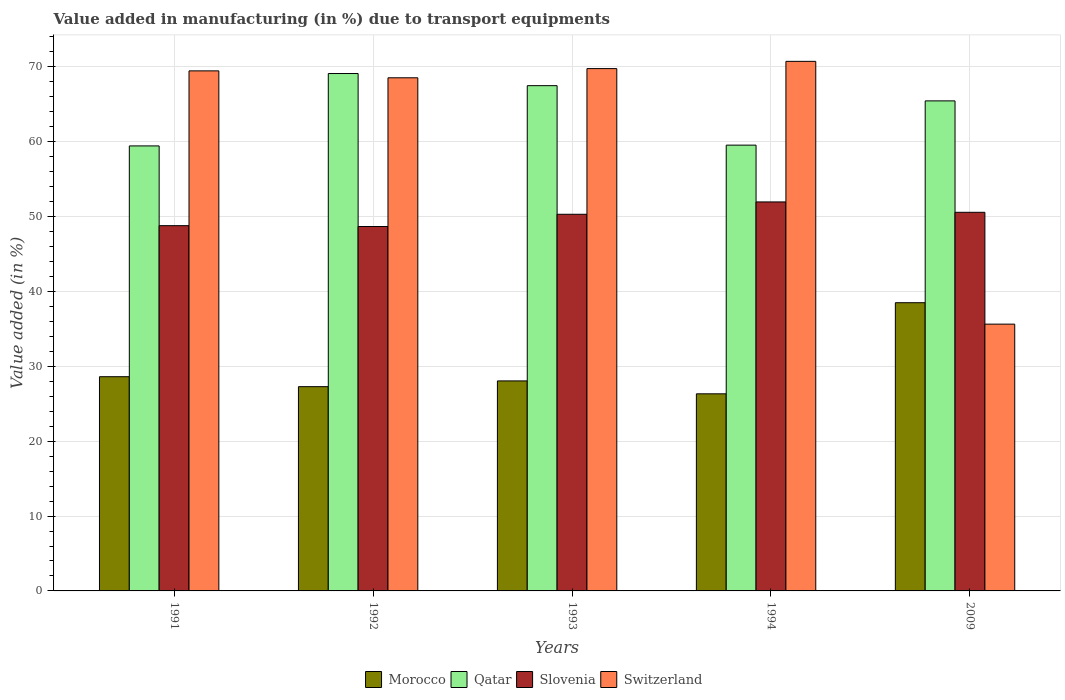How many different coloured bars are there?
Keep it short and to the point. 4. How many groups of bars are there?
Offer a very short reply. 5. Are the number of bars on each tick of the X-axis equal?
Make the answer very short. Yes. How many bars are there on the 4th tick from the left?
Make the answer very short. 4. How many bars are there on the 5th tick from the right?
Offer a very short reply. 4. In how many cases, is the number of bars for a given year not equal to the number of legend labels?
Give a very brief answer. 0. What is the percentage of value added in manufacturing due to transport equipments in Qatar in 1994?
Your response must be concise. 59.55. Across all years, what is the maximum percentage of value added in manufacturing due to transport equipments in Slovenia?
Your answer should be compact. 51.96. Across all years, what is the minimum percentage of value added in manufacturing due to transport equipments in Qatar?
Keep it short and to the point. 59.44. In which year was the percentage of value added in manufacturing due to transport equipments in Qatar maximum?
Make the answer very short. 1992. In which year was the percentage of value added in manufacturing due to transport equipments in Qatar minimum?
Offer a very short reply. 1991. What is the total percentage of value added in manufacturing due to transport equipments in Qatar in the graph?
Your response must be concise. 321.04. What is the difference between the percentage of value added in manufacturing due to transport equipments in Morocco in 1993 and that in 1994?
Provide a short and direct response. 1.72. What is the difference between the percentage of value added in manufacturing due to transport equipments in Qatar in 1993 and the percentage of value added in manufacturing due to transport equipments in Switzerland in 1994?
Provide a short and direct response. -3.25. What is the average percentage of value added in manufacturing due to transport equipments in Morocco per year?
Offer a very short reply. 29.75. In the year 1992, what is the difference between the percentage of value added in manufacturing due to transport equipments in Qatar and percentage of value added in manufacturing due to transport equipments in Switzerland?
Your answer should be compact. 0.57. In how many years, is the percentage of value added in manufacturing due to transport equipments in Morocco greater than 26 %?
Your answer should be very brief. 5. What is the ratio of the percentage of value added in manufacturing due to transport equipments in Qatar in 1993 to that in 2009?
Your answer should be very brief. 1.03. What is the difference between the highest and the second highest percentage of value added in manufacturing due to transport equipments in Qatar?
Offer a terse response. 1.62. What is the difference between the highest and the lowest percentage of value added in manufacturing due to transport equipments in Qatar?
Keep it short and to the point. 9.67. Is the sum of the percentage of value added in manufacturing due to transport equipments in Qatar in 1991 and 2009 greater than the maximum percentage of value added in manufacturing due to transport equipments in Morocco across all years?
Your answer should be very brief. Yes. What does the 4th bar from the left in 1993 represents?
Offer a very short reply. Switzerland. What does the 4th bar from the right in 1993 represents?
Provide a succinct answer. Morocco. Is it the case that in every year, the sum of the percentage of value added in manufacturing due to transport equipments in Morocco and percentage of value added in manufacturing due to transport equipments in Slovenia is greater than the percentage of value added in manufacturing due to transport equipments in Qatar?
Offer a terse response. Yes. Are all the bars in the graph horizontal?
Your answer should be very brief. No. How many years are there in the graph?
Give a very brief answer. 5. Are the values on the major ticks of Y-axis written in scientific E-notation?
Offer a terse response. No. Does the graph contain any zero values?
Your answer should be very brief. No. How many legend labels are there?
Make the answer very short. 4. How are the legend labels stacked?
Provide a succinct answer. Horizontal. What is the title of the graph?
Keep it short and to the point. Value added in manufacturing (in %) due to transport equipments. Does "Congo (Republic)" appear as one of the legend labels in the graph?
Offer a very short reply. No. What is the label or title of the X-axis?
Provide a succinct answer. Years. What is the label or title of the Y-axis?
Ensure brevity in your answer.  Value added (in %). What is the Value added (in %) in Morocco in 1991?
Give a very brief answer. 28.61. What is the Value added (in %) in Qatar in 1991?
Your response must be concise. 59.44. What is the Value added (in %) of Slovenia in 1991?
Provide a succinct answer. 48.79. What is the Value added (in %) of Switzerland in 1991?
Offer a terse response. 69.46. What is the Value added (in %) of Morocco in 1992?
Keep it short and to the point. 27.28. What is the Value added (in %) in Qatar in 1992?
Provide a short and direct response. 69.11. What is the Value added (in %) of Slovenia in 1992?
Offer a terse response. 48.68. What is the Value added (in %) in Switzerland in 1992?
Offer a very short reply. 68.54. What is the Value added (in %) in Morocco in 1993?
Ensure brevity in your answer.  28.05. What is the Value added (in %) in Qatar in 1993?
Make the answer very short. 67.49. What is the Value added (in %) of Slovenia in 1993?
Offer a very short reply. 50.31. What is the Value added (in %) of Switzerland in 1993?
Offer a terse response. 69.77. What is the Value added (in %) in Morocco in 1994?
Give a very brief answer. 26.33. What is the Value added (in %) of Qatar in 1994?
Ensure brevity in your answer.  59.55. What is the Value added (in %) in Slovenia in 1994?
Your response must be concise. 51.96. What is the Value added (in %) of Switzerland in 1994?
Provide a succinct answer. 70.74. What is the Value added (in %) of Morocco in 2009?
Give a very brief answer. 38.5. What is the Value added (in %) in Qatar in 2009?
Give a very brief answer. 65.46. What is the Value added (in %) of Slovenia in 2009?
Your response must be concise. 50.57. What is the Value added (in %) in Switzerland in 2009?
Make the answer very short. 35.64. Across all years, what is the maximum Value added (in %) of Morocco?
Give a very brief answer. 38.5. Across all years, what is the maximum Value added (in %) of Qatar?
Make the answer very short. 69.11. Across all years, what is the maximum Value added (in %) of Slovenia?
Provide a succinct answer. 51.96. Across all years, what is the maximum Value added (in %) in Switzerland?
Offer a very short reply. 70.74. Across all years, what is the minimum Value added (in %) in Morocco?
Give a very brief answer. 26.33. Across all years, what is the minimum Value added (in %) in Qatar?
Ensure brevity in your answer.  59.44. Across all years, what is the minimum Value added (in %) of Slovenia?
Ensure brevity in your answer.  48.68. Across all years, what is the minimum Value added (in %) in Switzerland?
Your answer should be very brief. 35.64. What is the total Value added (in %) in Morocco in the graph?
Your answer should be compact. 148.77. What is the total Value added (in %) of Qatar in the graph?
Make the answer very short. 321.04. What is the total Value added (in %) of Slovenia in the graph?
Ensure brevity in your answer.  250.31. What is the total Value added (in %) of Switzerland in the graph?
Your answer should be compact. 314.15. What is the difference between the Value added (in %) of Morocco in 1991 and that in 1992?
Make the answer very short. 1.33. What is the difference between the Value added (in %) of Qatar in 1991 and that in 1992?
Keep it short and to the point. -9.67. What is the difference between the Value added (in %) of Slovenia in 1991 and that in 1992?
Your response must be concise. 0.11. What is the difference between the Value added (in %) of Switzerland in 1991 and that in 1992?
Your response must be concise. 0.92. What is the difference between the Value added (in %) in Morocco in 1991 and that in 1993?
Make the answer very short. 0.56. What is the difference between the Value added (in %) of Qatar in 1991 and that in 1993?
Provide a short and direct response. -8.05. What is the difference between the Value added (in %) of Slovenia in 1991 and that in 1993?
Provide a short and direct response. -1.52. What is the difference between the Value added (in %) of Switzerland in 1991 and that in 1993?
Your answer should be very brief. -0.3. What is the difference between the Value added (in %) in Morocco in 1991 and that in 1994?
Keep it short and to the point. 2.29. What is the difference between the Value added (in %) in Qatar in 1991 and that in 1994?
Give a very brief answer. -0.1. What is the difference between the Value added (in %) of Slovenia in 1991 and that in 1994?
Your answer should be compact. -3.17. What is the difference between the Value added (in %) of Switzerland in 1991 and that in 1994?
Your answer should be very brief. -1.27. What is the difference between the Value added (in %) of Morocco in 1991 and that in 2009?
Ensure brevity in your answer.  -9.88. What is the difference between the Value added (in %) in Qatar in 1991 and that in 2009?
Give a very brief answer. -6.01. What is the difference between the Value added (in %) in Slovenia in 1991 and that in 2009?
Ensure brevity in your answer.  -1.78. What is the difference between the Value added (in %) in Switzerland in 1991 and that in 2009?
Your answer should be compact. 33.83. What is the difference between the Value added (in %) in Morocco in 1992 and that in 1993?
Your answer should be very brief. -0.77. What is the difference between the Value added (in %) in Qatar in 1992 and that in 1993?
Make the answer very short. 1.62. What is the difference between the Value added (in %) in Slovenia in 1992 and that in 1993?
Offer a terse response. -1.64. What is the difference between the Value added (in %) of Switzerland in 1992 and that in 1993?
Your answer should be very brief. -1.23. What is the difference between the Value added (in %) of Morocco in 1992 and that in 1994?
Offer a terse response. 0.95. What is the difference between the Value added (in %) in Qatar in 1992 and that in 1994?
Offer a very short reply. 9.57. What is the difference between the Value added (in %) in Slovenia in 1992 and that in 1994?
Offer a terse response. -3.29. What is the difference between the Value added (in %) of Switzerland in 1992 and that in 1994?
Offer a very short reply. -2.2. What is the difference between the Value added (in %) of Morocco in 1992 and that in 2009?
Offer a very short reply. -11.21. What is the difference between the Value added (in %) in Qatar in 1992 and that in 2009?
Make the answer very short. 3.65. What is the difference between the Value added (in %) in Slovenia in 1992 and that in 2009?
Give a very brief answer. -1.9. What is the difference between the Value added (in %) of Switzerland in 1992 and that in 2009?
Offer a terse response. 32.9. What is the difference between the Value added (in %) in Morocco in 1993 and that in 1994?
Your answer should be very brief. 1.72. What is the difference between the Value added (in %) of Qatar in 1993 and that in 1994?
Your response must be concise. 7.94. What is the difference between the Value added (in %) of Slovenia in 1993 and that in 1994?
Make the answer very short. -1.65. What is the difference between the Value added (in %) of Switzerland in 1993 and that in 1994?
Offer a terse response. -0.97. What is the difference between the Value added (in %) in Morocco in 1993 and that in 2009?
Your answer should be very brief. -10.45. What is the difference between the Value added (in %) in Qatar in 1993 and that in 2009?
Ensure brevity in your answer.  2.03. What is the difference between the Value added (in %) in Slovenia in 1993 and that in 2009?
Give a very brief answer. -0.26. What is the difference between the Value added (in %) in Switzerland in 1993 and that in 2009?
Offer a terse response. 34.13. What is the difference between the Value added (in %) of Morocco in 1994 and that in 2009?
Provide a short and direct response. -12.17. What is the difference between the Value added (in %) of Qatar in 1994 and that in 2009?
Offer a terse response. -5.91. What is the difference between the Value added (in %) of Slovenia in 1994 and that in 2009?
Give a very brief answer. 1.39. What is the difference between the Value added (in %) in Switzerland in 1994 and that in 2009?
Ensure brevity in your answer.  35.1. What is the difference between the Value added (in %) of Morocco in 1991 and the Value added (in %) of Qatar in 1992?
Your answer should be very brief. -40.5. What is the difference between the Value added (in %) in Morocco in 1991 and the Value added (in %) in Slovenia in 1992?
Offer a terse response. -20.06. What is the difference between the Value added (in %) of Morocco in 1991 and the Value added (in %) of Switzerland in 1992?
Your response must be concise. -39.93. What is the difference between the Value added (in %) in Qatar in 1991 and the Value added (in %) in Slovenia in 1992?
Offer a very short reply. 10.77. What is the difference between the Value added (in %) in Qatar in 1991 and the Value added (in %) in Switzerland in 1992?
Your response must be concise. -9.1. What is the difference between the Value added (in %) of Slovenia in 1991 and the Value added (in %) of Switzerland in 1992?
Offer a very short reply. -19.75. What is the difference between the Value added (in %) in Morocco in 1991 and the Value added (in %) in Qatar in 1993?
Your response must be concise. -38.88. What is the difference between the Value added (in %) in Morocco in 1991 and the Value added (in %) in Slovenia in 1993?
Your answer should be very brief. -21.7. What is the difference between the Value added (in %) in Morocco in 1991 and the Value added (in %) in Switzerland in 1993?
Make the answer very short. -41.15. What is the difference between the Value added (in %) in Qatar in 1991 and the Value added (in %) in Slovenia in 1993?
Keep it short and to the point. 9.13. What is the difference between the Value added (in %) in Qatar in 1991 and the Value added (in %) in Switzerland in 1993?
Give a very brief answer. -10.33. What is the difference between the Value added (in %) in Slovenia in 1991 and the Value added (in %) in Switzerland in 1993?
Ensure brevity in your answer.  -20.98. What is the difference between the Value added (in %) in Morocco in 1991 and the Value added (in %) in Qatar in 1994?
Your answer should be compact. -30.93. What is the difference between the Value added (in %) of Morocco in 1991 and the Value added (in %) of Slovenia in 1994?
Your answer should be very brief. -23.35. What is the difference between the Value added (in %) in Morocco in 1991 and the Value added (in %) in Switzerland in 1994?
Make the answer very short. -42.12. What is the difference between the Value added (in %) in Qatar in 1991 and the Value added (in %) in Slovenia in 1994?
Your response must be concise. 7.48. What is the difference between the Value added (in %) of Qatar in 1991 and the Value added (in %) of Switzerland in 1994?
Ensure brevity in your answer.  -11.29. What is the difference between the Value added (in %) in Slovenia in 1991 and the Value added (in %) in Switzerland in 1994?
Provide a short and direct response. -21.95. What is the difference between the Value added (in %) in Morocco in 1991 and the Value added (in %) in Qatar in 2009?
Give a very brief answer. -36.84. What is the difference between the Value added (in %) of Morocco in 1991 and the Value added (in %) of Slovenia in 2009?
Your answer should be compact. -21.96. What is the difference between the Value added (in %) in Morocco in 1991 and the Value added (in %) in Switzerland in 2009?
Your answer should be compact. -7.02. What is the difference between the Value added (in %) in Qatar in 1991 and the Value added (in %) in Slovenia in 2009?
Provide a short and direct response. 8.87. What is the difference between the Value added (in %) of Qatar in 1991 and the Value added (in %) of Switzerland in 2009?
Provide a succinct answer. 23.81. What is the difference between the Value added (in %) of Slovenia in 1991 and the Value added (in %) of Switzerland in 2009?
Your answer should be compact. 13.15. What is the difference between the Value added (in %) of Morocco in 1992 and the Value added (in %) of Qatar in 1993?
Provide a short and direct response. -40.21. What is the difference between the Value added (in %) of Morocco in 1992 and the Value added (in %) of Slovenia in 1993?
Ensure brevity in your answer.  -23.03. What is the difference between the Value added (in %) of Morocco in 1992 and the Value added (in %) of Switzerland in 1993?
Provide a short and direct response. -42.48. What is the difference between the Value added (in %) of Qatar in 1992 and the Value added (in %) of Slovenia in 1993?
Your response must be concise. 18.8. What is the difference between the Value added (in %) in Qatar in 1992 and the Value added (in %) in Switzerland in 1993?
Keep it short and to the point. -0.66. What is the difference between the Value added (in %) of Slovenia in 1992 and the Value added (in %) of Switzerland in 1993?
Give a very brief answer. -21.09. What is the difference between the Value added (in %) in Morocco in 1992 and the Value added (in %) in Qatar in 1994?
Provide a succinct answer. -32.26. What is the difference between the Value added (in %) in Morocco in 1992 and the Value added (in %) in Slovenia in 1994?
Ensure brevity in your answer.  -24.68. What is the difference between the Value added (in %) of Morocco in 1992 and the Value added (in %) of Switzerland in 1994?
Provide a succinct answer. -43.45. What is the difference between the Value added (in %) in Qatar in 1992 and the Value added (in %) in Slovenia in 1994?
Provide a succinct answer. 17.15. What is the difference between the Value added (in %) of Qatar in 1992 and the Value added (in %) of Switzerland in 1994?
Provide a succinct answer. -1.63. What is the difference between the Value added (in %) of Slovenia in 1992 and the Value added (in %) of Switzerland in 1994?
Keep it short and to the point. -22.06. What is the difference between the Value added (in %) of Morocco in 1992 and the Value added (in %) of Qatar in 2009?
Offer a terse response. -38.17. What is the difference between the Value added (in %) of Morocco in 1992 and the Value added (in %) of Slovenia in 2009?
Your response must be concise. -23.29. What is the difference between the Value added (in %) of Morocco in 1992 and the Value added (in %) of Switzerland in 2009?
Offer a terse response. -8.35. What is the difference between the Value added (in %) in Qatar in 1992 and the Value added (in %) in Slovenia in 2009?
Keep it short and to the point. 18.54. What is the difference between the Value added (in %) in Qatar in 1992 and the Value added (in %) in Switzerland in 2009?
Your response must be concise. 33.48. What is the difference between the Value added (in %) in Slovenia in 1992 and the Value added (in %) in Switzerland in 2009?
Make the answer very short. 13.04. What is the difference between the Value added (in %) in Morocco in 1993 and the Value added (in %) in Qatar in 1994?
Your answer should be compact. -31.49. What is the difference between the Value added (in %) of Morocco in 1993 and the Value added (in %) of Slovenia in 1994?
Your answer should be compact. -23.91. What is the difference between the Value added (in %) in Morocco in 1993 and the Value added (in %) in Switzerland in 1994?
Keep it short and to the point. -42.69. What is the difference between the Value added (in %) in Qatar in 1993 and the Value added (in %) in Slovenia in 1994?
Provide a short and direct response. 15.53. What is the difference between the Value added (in %) of Qatar in 1993 and the Value added (in %) of Switzerland in 1994?
Ensure brevity in your answer.  -3.25. What is the difference between the Value added (in %) in Slovenia in 1993 and the Value added (in %) in Switzerland in 1994?
Make the answer very short. -20.43. What is the difference between the Value added (in %) of Morocco in 1993 and the Value added (in %) of Qatar in 2009?
Keep it short and to the point. -37.41. What is the difference between the Value added (in %) of Morocco in 1993 and the Value added (in %) of Slovenia in 2009?
Provide a succinct answer. -22.52. What is the difference between the Value added (in %) of Morocco in 1993 and the Value added (in %) of Switzerland in 2009?
Keep it short and to the point. -7.58. What is the difference between the Value added (in %) in Qatar in 1993 and the Value added (in %) in Slovenia in 2009?
Your response must be concise. 16.92. What is the difference between the Value added (in %) in Qatar in 1993 and the Value added (in %) in Switzerland in 2009?
Your answer should be compact. 31.85. What is the difference between the Value added (in %) of Slovenia in 1993 and the Value added (in %) of Switzerland in 2009?
Offer a very short reply. 14.67. What is the difference between the Value added (in %) of Morocco in 1994 and the Value added (in %) of Qatar in 2009?
Offer a very short reply. -39.13. What is the difference between the Value added (in %) in Morocco in 1994 and the Value added (in %) in Slovenia in 2009?
Your answer should be compact. -24.24. What is the difference between the Value added (in %) in Morocco in 1994 and the Value added (in %) in Switzerland in 2009?
Your response must be concise. -9.31. What is the difference between the Value added (in %) of Qatar in 1994 and the Value added (in %) of Slovenia in 2009?
Make the answer very short. 8.97. What is the difference between the Value added (in %) in Qatar in 1994 and the Value added (in %) in Switzerland in 2009?
Provide a short and direct response. 23.91. What is the difference between the Value added (in %) of Slovenia in 1994 and the Value added (in %) of Switzerland in 2009?
Make the answer very short. 16.32. What is the average Value added (in %) in Morocco per year?
Make the answer very short. 29.75. What is the average Value added (in %) of Qatar per year?
Offer a terse response. 64.21. What is the average Value added (in %) of Slovenia per year?
Your response must be concise. 50.06. What is the average Value added (in %) in Switzerland per year?
Offer a terse response. 62.83. In the year 1991, what is the difference between the Value added (in %) in Morocco and Value added (in %) in Qatar?
Ensure brevity in your answer.  -30.83. In the year 1991, what is the difference between the Value added (in %) in Morocco and Value added (in %) in Slovenia?
Make the answer very short. -20.18. In the year 1991, what is the difference between the Value added (in %) in Morocco and Value added (in %) in Switzerland?
Offer a very short reply. -40.85. In the year 1991, what is the difference between the Value added (in %) in Qatar and Value added (in %) in Slovenia?
Offer a very short reply. 10.65. In the year 1991, what is the difference between the Value added (in %) of Qatar and Value added (in %) of Switzerland?
Keep it short and to the point. -10.02. In the year 1991, what is the difference between the Value added (in %) of Slovenia and Value added (in %) of Switzerland?
Offer a very short reply. -20.68. In the year 1992, what is the difference between the Value added (in %) in Morocco and Value added (in %) in Qatar?
Your response must be concise. -41.83. In the year 1992, what is the difference between the Value added (in %) of Morocco and Value added (in %) of Slovenia?
Give a very brief answer. -21.39. In the year 1992, what is the difference between the Value added (in %) in Morocco and Value added (in %) in Switzerland?
Make the answer very short. -41.26. In the year 1992, what is the difference between the Value added (in %) in Qatar and Value added (in %) in Slovenia?
Ensure brevity in your answer.  20.44. In the year 1992, what is the difference between the Value added (in %) in Qatar and Value added (in %) in Switzerland?
Offer a very short reply. 0.57. In the year 1992, what is the difference between the Value added (in %) of Slovenia and Value added (in %) of Switzerland?
Give a very brief answer. -19.87. In the year 1993, what is the difference between the Value added (in %) of Morocco and Value added (in %) of Qatar?
Make the answer very short. -39.44. In the year 1993, what is the difference between the Value added (in %) of Morocco and Value added (in %) of Slovenia?
Your answer should be very brief. -22.26. In the year 1993, what is the difference between the Value added (in %) of Morocco and Value added (in %) of Switzerland?
Offer a terse response. -41.72. In the year 1993, what is the difference between the Value added (in %) of Qatar and Value added (in %) of Slovenia?
Provide a short and direct response. 17.18. In the year 1993, what is the difference between the Value added (in %) in Qatar and Value added (in %) in Switzerland?
Provide a succinct answer. -2.28. In the year 1993, what is the difference between the Value added (in %) of Slovenia and Value added (in %) of Switzerland?
Give a very brief answer. -19.46. In the year 1994, what is the difference between the Value added (in %) of Morocco and Value added (in %) of Qatar?
Your answer should be very brief. -33.22. In the year 1994, what is the difference between the Value added (in %) of Morocco and Value added (in %) of Slovenia?
Provide a succinct answer. -25.63. In the year 1994, what is the difference between the Value added (in %) in Morocco and Value added (in %) in Switzerland?
Make the answer very short. -44.41. In the year 1994, what is the difference between the Value added (in %) in Qatar and Value added (in %) in Slovenia?
Keep it short and to the point. 7.59. In the year 1994, what is the difference between the Value added (in %) in Qatar and Value added (in %) in Switzerland?
Give a very brief answer. -11.19. In the year 1994, what is the difference between the Value added (in %) in Slovenia and Value added (in %) in Switzerland?
Keep it short and to the point. -18.78. In the year 2009, what is the difference between the Value added (in %) of Morocco and Value added (in %) of Qatar?
Ensure brevity in your answer.  -26.96. In the year 2009, what is the difference between the Value added (in %) in Morocco and Value added (in %) in Slovenia?
Offer a terse response. -12.08. In the year 2009, what is the difference between the Value added (in %) in Morocco and Value added (in %) in Switzerland?
Provide a short and direct response. 2.86. In the year 2009, what is the difference between the Value added (in %) of Qatar and Value added (in %) of Slovenia?
Offer a very short reply. 14.88. In the year 2009, what is the difference between the Value added (in %) in Qatar and Value added (in %) in Switzerland?
Your answer should be very brief. 29.82. In the year 2009, what is the difference between the Value added (in %) of Slovenia and Value added (in %) of Switzerland?
Offer a very short reply. 14.94. What is the ratio of the Value added (in %) in Morocco in 1991 to that in 1992?
Make the answer very short. 1.05. What is the ratio of the Value added (in %) in Qatar in 1991 to that in 1992?
Keep it short and to the point. 0.86. What is the ratio of the Value added (in %) of Slovenia in 1991 to that in 1992?
Provide a succinct answer. 1. What is the ratio of the Value added (in %) of Switzerland in 1991 to that in 1992?
Make the answer very short. 1.01. What is the ratio of the Value added (in %) of Morocco in 1991 to that in 1993?
Offer a terse response. 1.02. What is the ratio of the Value added (in %) of Qatar in 1991 to that in 1993?
Your answer should be very brief. 0.88. What is the ratio of the Value added (in %) in Slovenia in 1991 to that in 1993?
Offer a very short reply. 0.97. What is the ratio of the Value added (in %) of Switzerland in 1991 to that in 1993?
Your response must be concise. 1. What is the ratio of the Value added (in %) in Morocco in 1991 to that in 1994?
Give a very brief answer. 1.09. What is the ratio of the Value added (in %) of Slovenia in 1991 to that in 1994?
Make the answer very short. 0.94. What is the ratio of the Value added (in %) in Switzerland in 1991 to that in 1994?
Provide a succinct answer. 0.98. What is the ratio of the Value added (in %) in Morocco in 1991 to that in 2009?
Offer a terse response. 0.74. What is the ratio of the Value added (in %) in Qatar in 1991 to that in 2009?
Give a very brief answer. 0.91. What is the ratio of the Value added (in %) in Slovenia in 1991 to that in 2009?
Your response must be concise. 0.96. What is the ratio of the Value added (in %) of Switzerland in 1991 to that in 2009?
Offer a very short reply. 1.95. What is the ratio of the Value added (in %) of Morocco in 1992 to that in 1993?
Provide a short and direct response. 0.97. What is the ratio of the Value added (in %) of Qatar in 1992 to that in 1993?
Make the answer very short. 1.02. What is the ratio of the Value added (in %) in Slovenia in 1992 to that in 1993?
Make the answer very short. 0.97. What is the ratio of the Value added (in %) of Switzerland in 1992 to that in 1993?
Your answer should be compact. 0.98. What is the ratio of the Value added (in %) in Morocco in 1992 to that in 1994?
Provide a short and direct response. 1.04. What is the ratio of the Value added (in %) of Qatar in 1992 to that in 1994?
Offer a very short reply. 1.16. What is the ratio of the Value added (in %) of Slovenia in 1992 to that in 1994?
Provide a short and direct response. 0.94. What is the ratio of the Value added (in %) of Morocco in 1992 to that in 2009?
Your answer should be very brief. 0.71. What is the ratio of the Value added (in %) of Qatar in 1992 to that in 2009?
Offer a very short reply. 1.06. What is the ratio of the Value added (in %) in Slovenia in 1992 to that in 2009?
Make the answer very short. 0.96. What is the ratio of the Value added (in %) in Switzerland in 1992 to that in 2009?
Your response must be concise. 1.92. What is the ratio of the Value added (in %) in Morocco in 1993 to that in 1994?
Make the answer very short. 1.07. What is the ratio of the Value added (in %) of Qatar in 1993 to that in 1994?
Make the answer very short. 1.13. What is the ratio of the Value added (in %) of Slovenia in 1993 to that in 1994?
Give a very brief answer. 0.97. What is the ratio of the Value added (in %) in Switzerland in 1993 to that in 1994?
Give a very brief answer. 0.99. What is the ratio of the Value added (in %) in Morocco in 1993 to that in 2009?
Offer a very short reply. 0.73. What is the ratio of the Value added (in %) in Qatar in 1993 to that in 2009?
Provide a short and direct response. 1.03. What is the ratio of the Value added (in %) of Switzerland in 1993 to that in 2009?
Offer a terse response. 1.96. What is the ratio of the Value added (in %) in Morocco in 1994 to that in 2009?
Provide a succinct answer. 0.68. What is the ratio of the Value added (in %) in Qatar in 1994 to that in 2009?
Make the answer very short. 0.91. What is the ratio of the Value added (in %) in Slovenia in 1994 to that in 2009?
Give a very brief answer. 1.03. What is the ratio of the Value added (in %) of Switzerland in 1994 to that in 2009?
Provide a succinct answer. 1.99. What is the difference between the highest and the second highest Value added (in %) in Morocco?
Provide a succinct answer. 9.88. What is the difference between the highest and the second highest Value added (in %) of Qatar?
Provide a short and direct response. 1.62. What is the difference between the highest and the second highest Value added (in %) in Slovenia?
Offer a terse response. 1.39. What is the difference between the highest and the second highest Value added (in %) in Switzerland?
Your answer should be very brief. 0.97. What is the difference between the highest and the lowest Value added (in %) of Morocco?
Your answer should be compact. 12.17. What is the difference between the highest and the lowest Value added (in %) in Qatar?
Your answer should be very brief. 9.67. What is the difference between the highest and the lowest Value added (in %) in Slovenia?
Offer a terse response. 3.29. What is the difference between the highest and the lowest Value added (in %) in Switzerland?
Provide a succinct answer. 35.1. 